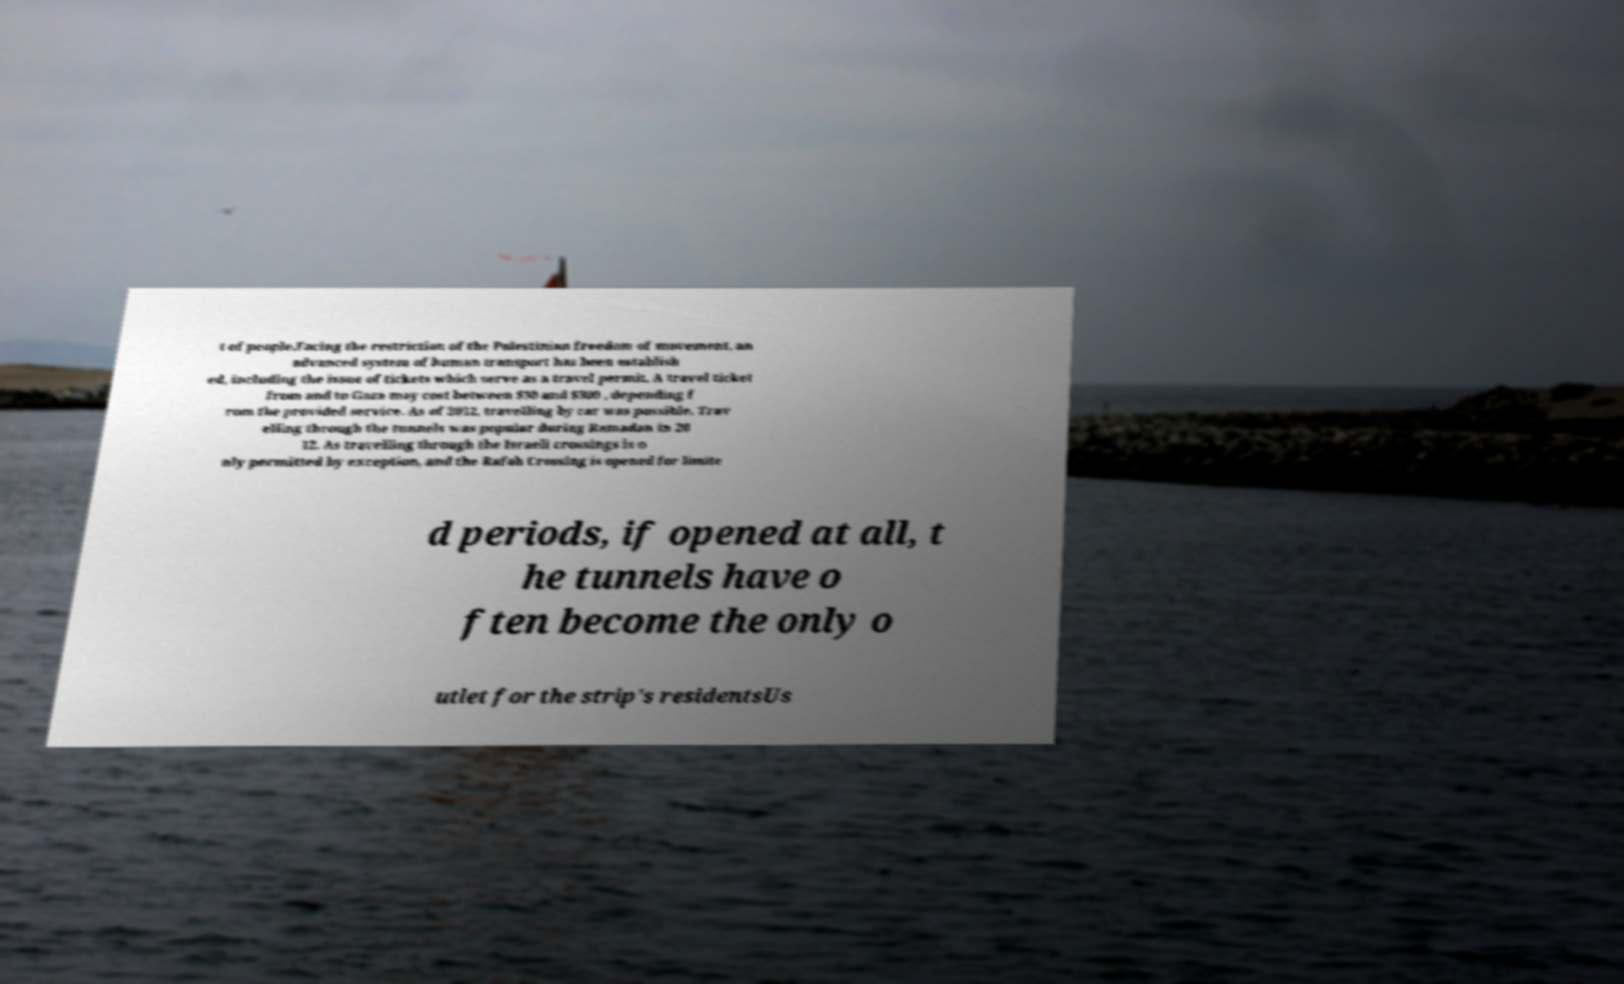There's text embedded in this image that I need extracted. Can you transcribe it verbatim? t of people.Facing the restriction of the Palestinian freedom of movement, an advanced system of human transport has been establish ed, including the issue of tickets which serve as a travel permit. A travel ticket from and to Gaza may cost between $30 and $300 , depending f rom the provided service. As of 2012, travelling by car was possible. Trav elling through the tunnels was popular during Ramadan in 20 12. As travelling through the Israeli crossings is o nly permitted by exception, and the Rafah Crossing is opened for limite d periods, if opened at all, t he tunnels have o ften become the only o utlet for the strip's residentsUs 